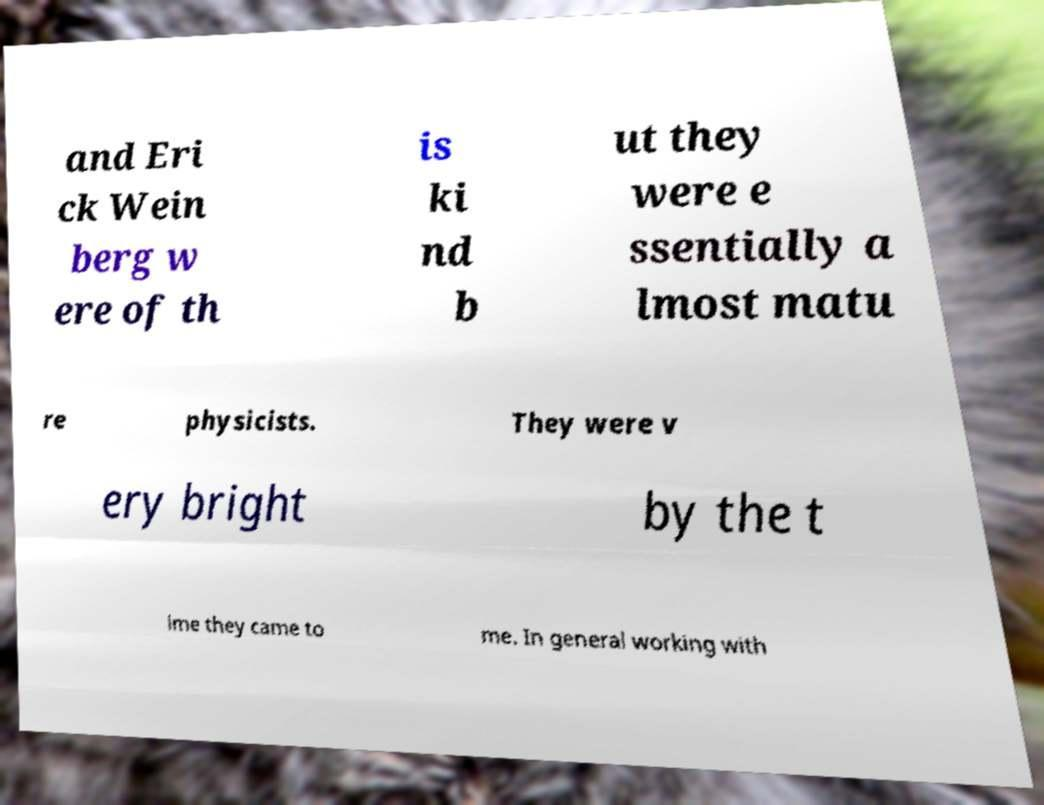What messages or text are displayed in this image? I need them in a readable, typed format. The image displays the text: 'and Eri ck Wein berg w ere of th is ki nd b ut they were e ssentially a lmost matu re physicists. They were v ery bright by the t ime they came to me. In general working with' 